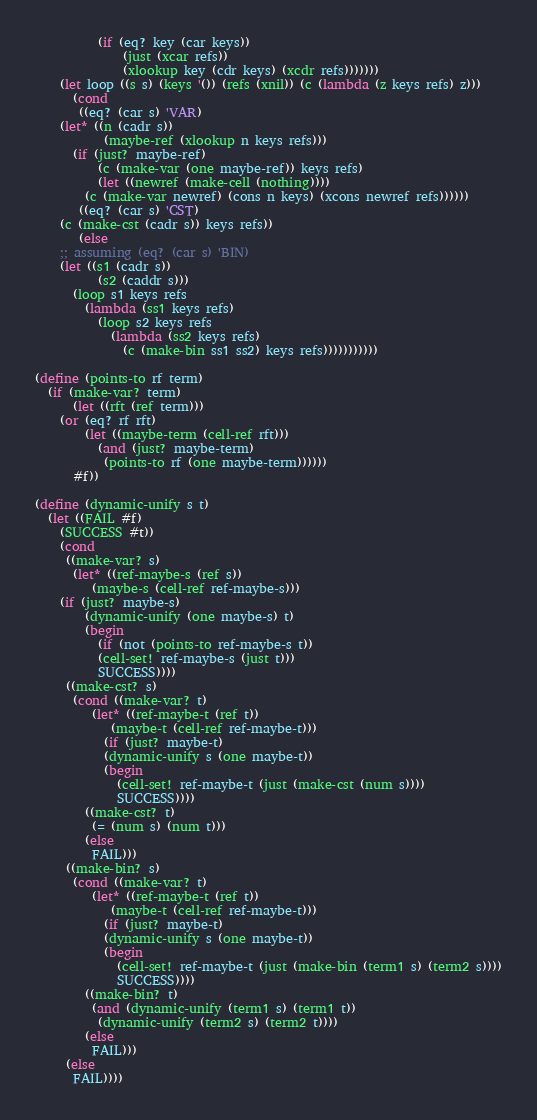<code> <loc_0><loc_0><loc_500><loc_500><_Scheme_>		  (if (eq? key (car keys))
		      (just (xcar refs))
		      (xlookup key (cdr keys) (xcdr refs)))))))
    (let loop ((s s) (keys '()) (refs (xnil)) (c (lambda (z keys refs) z)))
      (cond
       ((eq? (car s) 'VAR)
	(let* ((n (cadr s))
	       (maybe-ref (xlookup n keys refs)))
	  (if (just? maybe-ref)
	      (c (make-var (one maybe-ref)) keys refs)
	      (let ((newref (make-cell (nothing))))
		(c (make-var newref) (cons n keys) (xcons newref refs))))))
       ((eq? (car s) 'CST)
	(c (make-cst (cadr s)) keys refs))
       (else
	;; assuming (eq? (car s) 'BIN)
	(let ((s1 (cadr s))
	      (s2 (caddr s)))
	  (loop s1 keys refs
		(lambda (ss1 keys refs)
		  (loop s2 keys refs
			(lambda (ss2 keys refs)
			  (c (make-bin ss1 ss2) keys refs)))))))))))

(define (points-to rf term)
  (if (make-var? term)
      (let ((rft (ref term)))
	(or (eq? rf rft)
	    (let ((maybe-term (cell-ref rft)))
	      (and (just? maybe-term)
		   (points-to rf (one maybe-term))))))
      #f))

(define (dynamic-unify s t)
  (let ((FAIL #f)
	(SUCCESS #t))
    (cond
     ((make-var? s)
      (let* ((ref-maybe-s (ref s))
	     (maybe-s (cell-ref ref-maybe-s)))
	(if (just? maybe-s)
	    (dynamic-unify (one maybe-s) t)
	    (begin
	      (if (not (points-to ref-maybe-s t))
		  (cell-set! ref-maybe-s (just t)))
	      SUCCESS))))
     ((make-cst? s)
      (cond ((make-var? t)
	     (let* ((ref-maybe-t (ref t))
		    (maybe-t (cell-ref ref-maybe-t)))
	       (if (just? maybe-t)
		   (dynamic-unify s (one maybe-t))
		   (begin
		     (cell-set! ref-maybe-t (just (make-cst (num s))))
		     SUCCESS))))
	    ((make-cst? t)
	     (= (num s) (num t)))
	    (else
	     FAIL)))
     ((make-bin? s)
      (cond ((make-var? t)
	     (let* ((ref-maybe-t (ref t))
		    (maybe-t (cell-ref ref-maybe-t)))
	       (if (just? maybe-t)
		   (dynamic-unify s (one maybe-t))
		   (begin
		     (cell-set! ref-maybe-t (just (make-bin (term1 s) (term2 s))))
		     SUCCESS))))
	    ((make-bin? t)
	     (and (dynamic-unify (term1 s) (term1 t))
		  (dynamic-unify (term2 s) (term2 t))))
	    (else
	     FAIL)))
     (else
      FAIL))))
</code> 